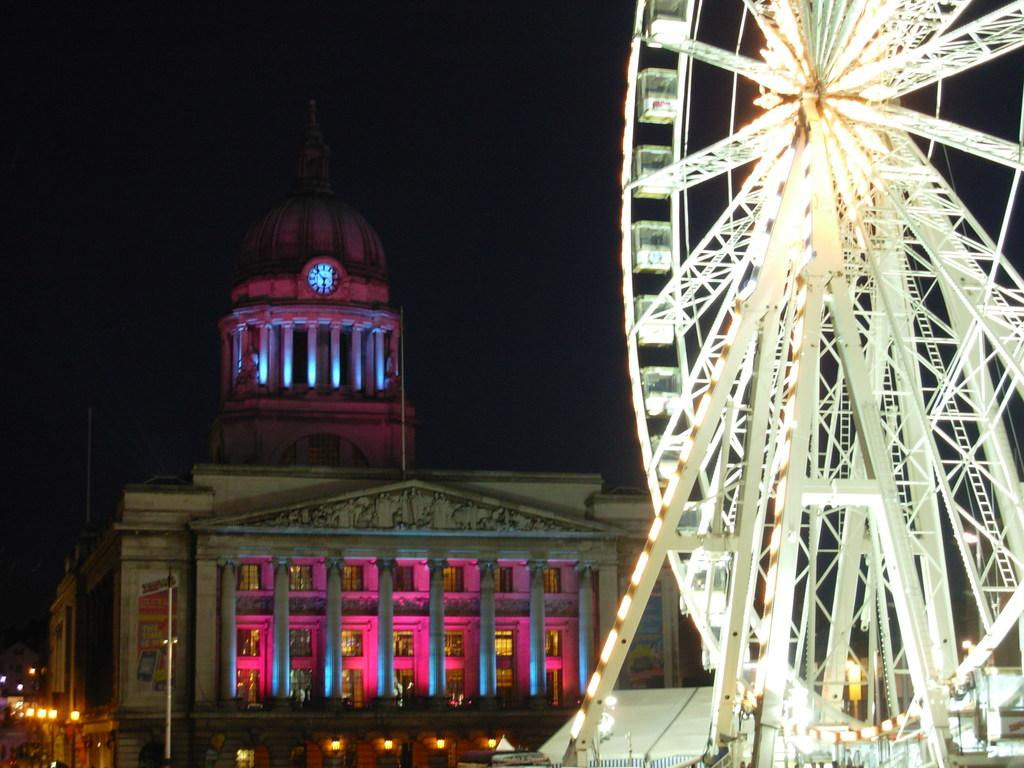What is the main feature on the right side of the image? There is a giant wheel on the right side of the image. What can be seen in the background of the image? There is a building in the background of the image. How would you describe the lighting in the image? The sky is completely dark in the image. What type of joke is the pig telling on the left side of the image? There is no pig or joke present in the image; it only features a giant wheel and a building in the background. 